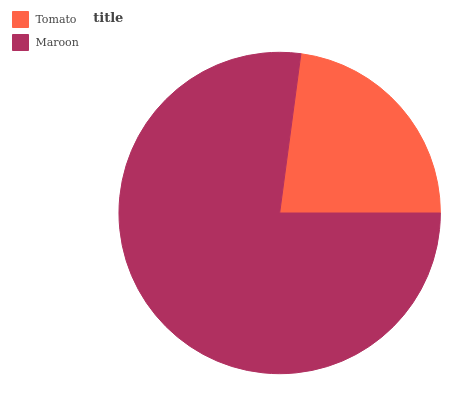Is Tomato the minimum?
Answer yes or no. Yes. Is Maroon the maximum?
Answer yes or no. Yes. Is Maroon the minimum?
Answer yes or no. No. Is Maroon greater than Tomato?
Answer yes or no. Yes. Is Tomato less than Maroon?
Answer yes or no. Yes. Is Tomato greater than Maroon?
Answer yes or no. No. Is Maroon less than Tomato?
Answer yes or no. No. Is Maroon the high median?
Answer yes or no. Yes. Is Tomato the low median?
Answer yes or no. Yes. Is Tomato the high median?
Answer yes or no. No. Is Maroon the low median?
Answer yes or no. No. 